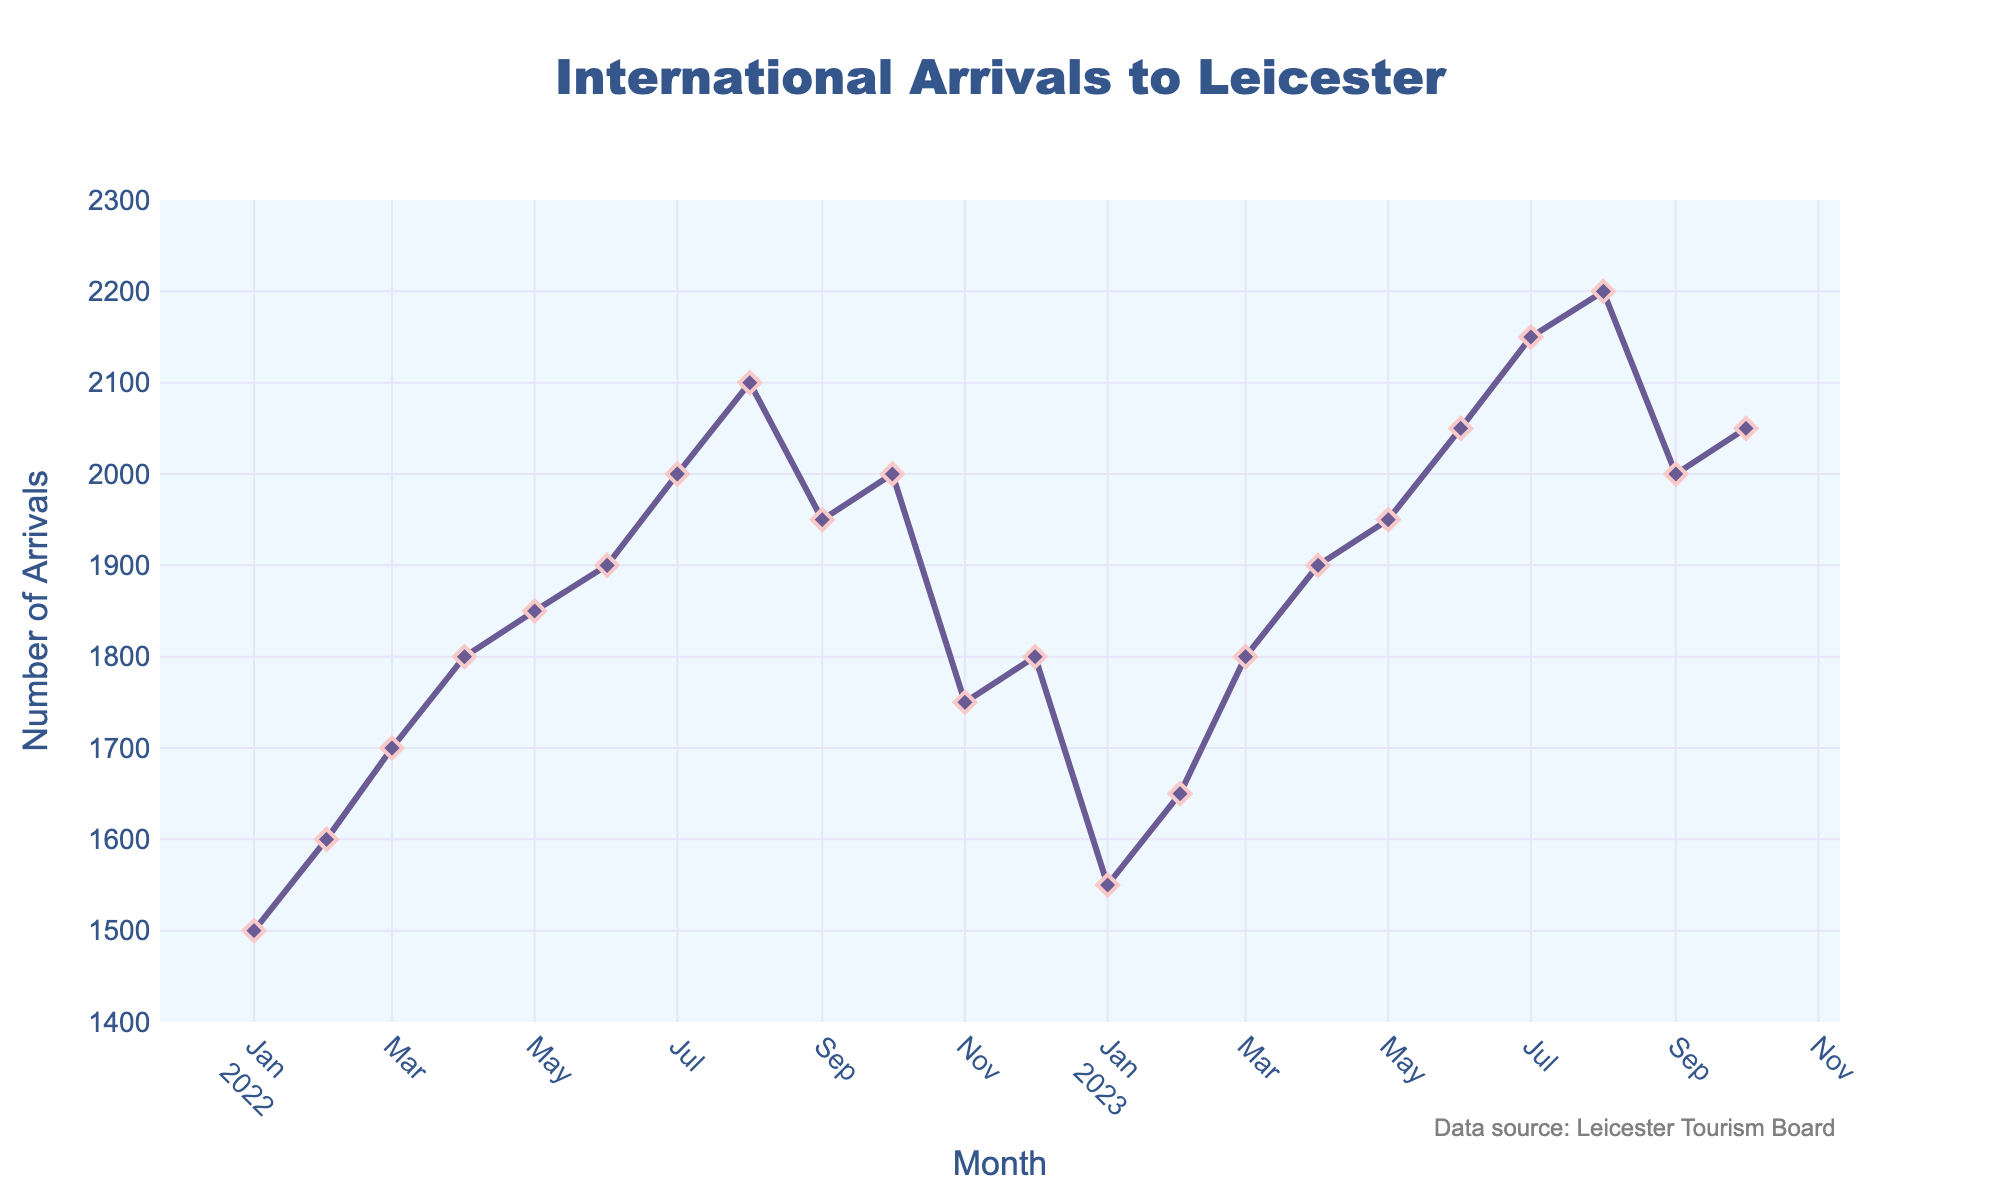How many international arrivals were recorded in October 2022? Look for the data point corresponding to October 2022 on the x-axis and check the value of the y-axis for that month.
Answer: 2000 What is the trend of international arrivals from January 2022 to December 2022? Observe the changes in the y-axis values month by month from January 2022 to December 2022.
Answer: Generally increasing with fluctuations What is the difference in international arrivals between August 2022 and August 2023? Find the values for August 2022 and August 2023, then calculate the difference: 2200 (August 2023) - 2100 (August 2022).
Answer: 100 Which month shows the highest number of international arrivals? Identify the peak of the plot by checking the highest y-axis value and correlate it with the corresponding x-axis value.
Answer: August 2023 In which month did international arrivals first exceed 2000? Look for the first occurrence on the plot where the y-axis value surpasses 2000 and identify the corresponding x-axis value.
Answer: August 2022 By how much did international arrivals change from July 2023 to August 2023? Compare the y-axis values for July 2023 and August 2023, then compute the difference: 2200 (August 2023) - 2150 (July 2023).
Answer: 50 What is the title of the plot? The title is located at the top center of the plot.
Answer: International Arrivals to Leicester What is the average number of international arrivals from January 2022 to October 2023? Add all the y-axis values from January 2022 to October 2023, then divide by the number of months (22): (sum of y-values) / 22.
Answer: 1862.5 What period shows the most stable number of international arrivals? Identify the segment of the plot where the y-axis values change the least over consecutive months.
Answer: The period from October 2022 to January 2023 What is the color of the line representing international arrivals? Observe the visual appearance of the line on the plot.
Answer: Purple 